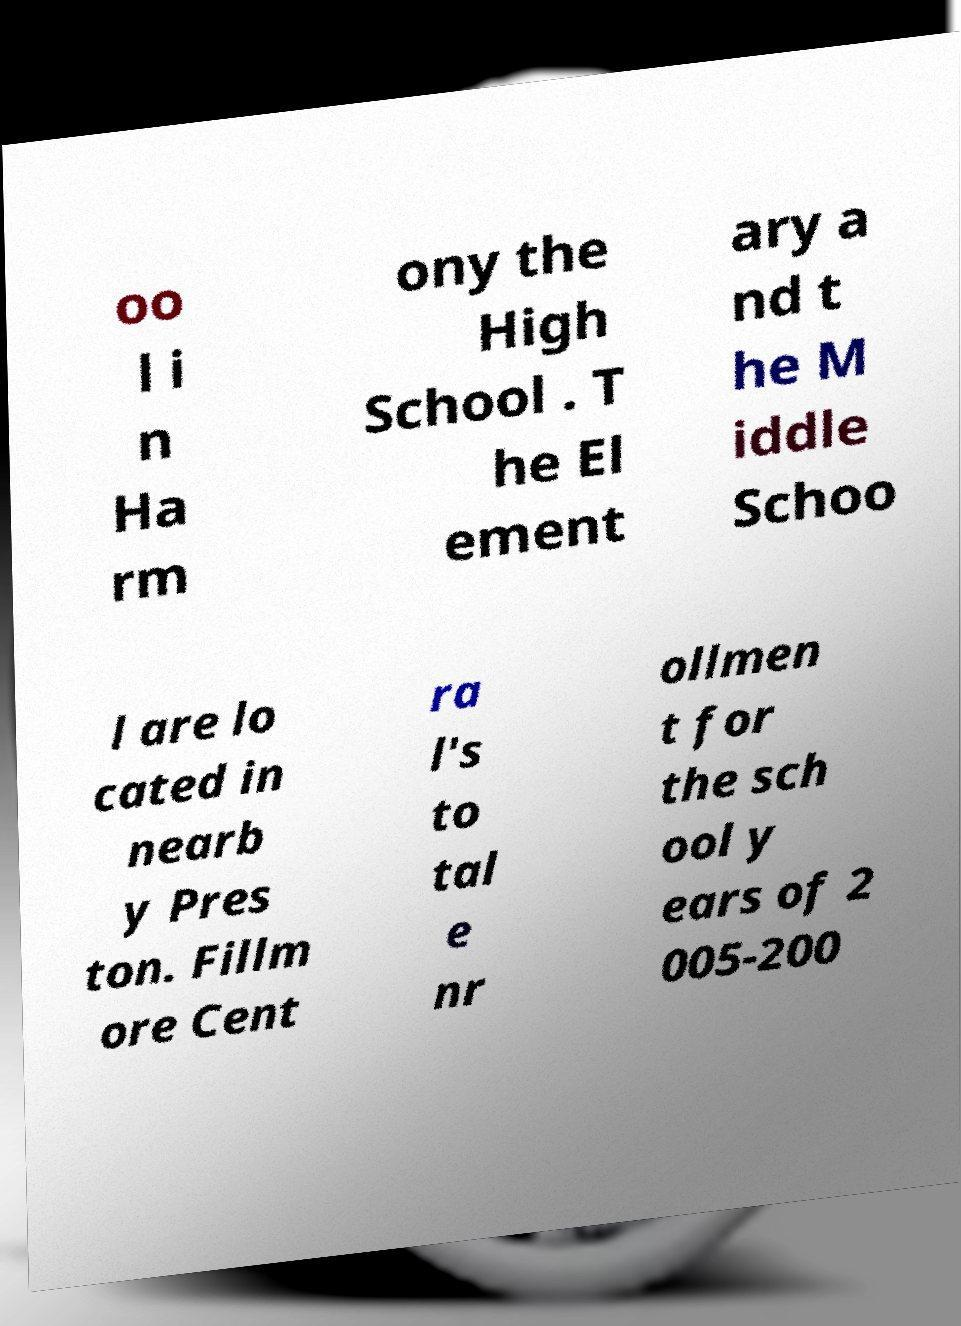Please read and relay the text visible in this image. What does it say? oo l i n Ha rm ony the High School . T he El ement ary a nd t he M iddle Schoo l are lo cated in nearb y Pres ton. Fillm ore Cent ra l's to tal e nr ollmen t for the sch ool y ears of 2 005-200 